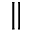Convert formula to latex. <formula><loc_0><loc_0><loc_500><loc_500>\|</formula> 